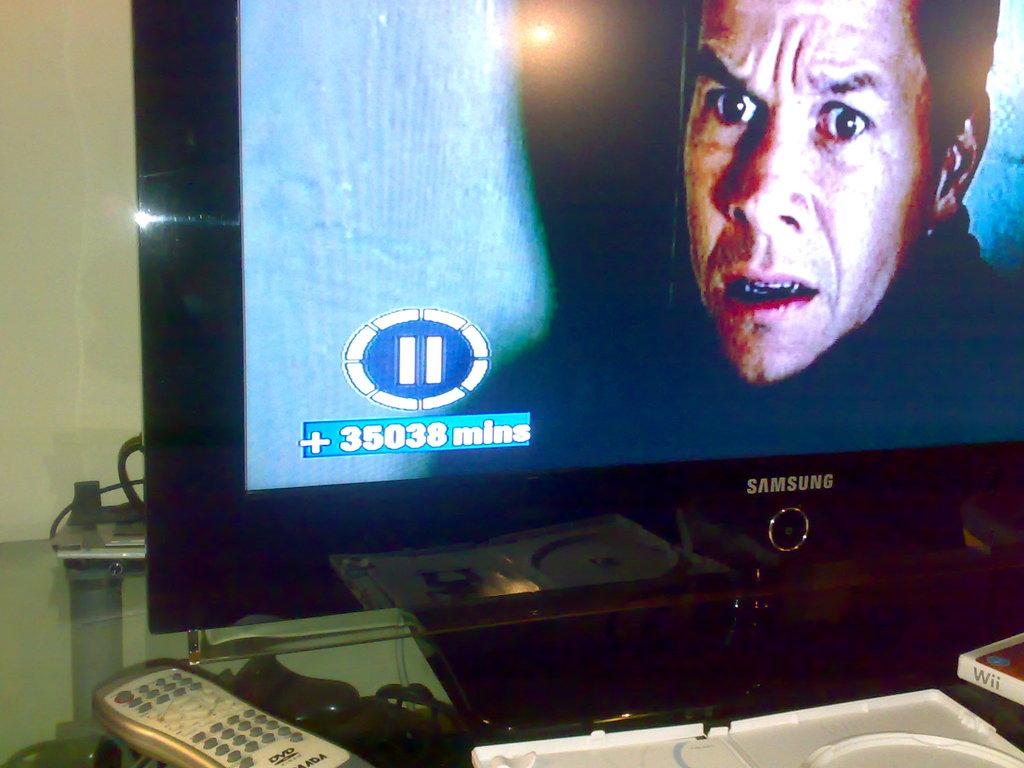What brand tv is this?
Ensure brevity in your answer.  Samsung. 